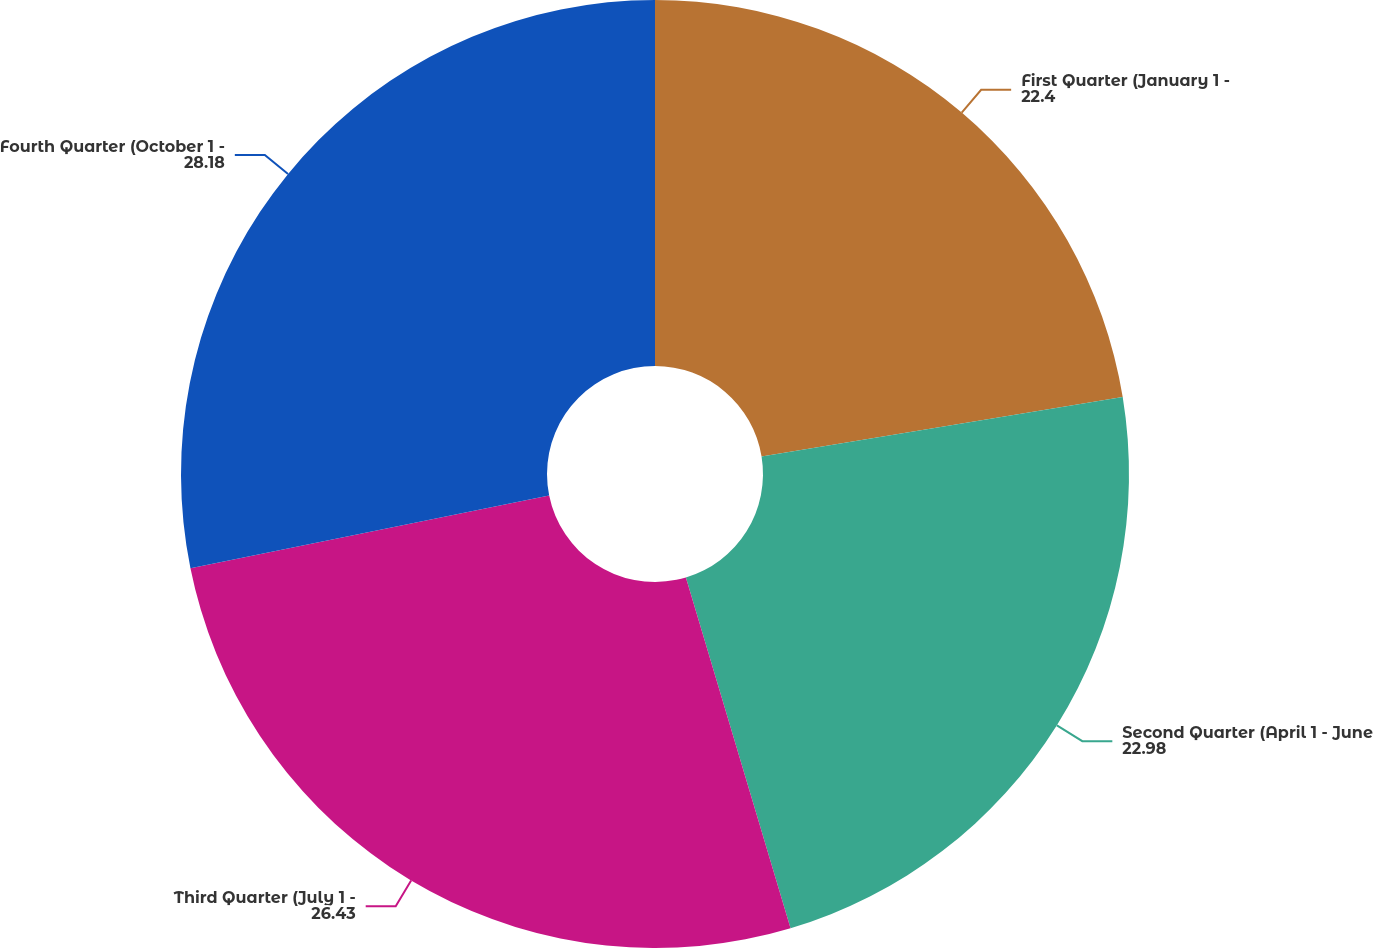<chart> <loc_0><loc_0><loc_500><loc_500><pie_chart><fcel>First Quarter (January 1 -<fcel>Second Quarter (April 1 - June<fcel>Third Quarter (July 1 -<fcel>Fourth Quarter (October 1 -<nl><fcel>22.4%<fcel>22.98%<fcel>26.43%<fcel>28.18%<nl></chart> 